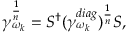<formula> <loc_0><loc_0><loc_500><loc_500>\gamma _ { \omega _ { k } } ^ { \frac { 1 } { n } } = S ^ { \dagger } ( \gamma _ { \omega _ { k } } ^ { d i a g } ) ^ { \frac { 1 } { n } } S ,</formula> 